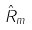<formula> <loc_0><loc_0><loc_500><loc_500>\hat { R } _ { m }</formula> 